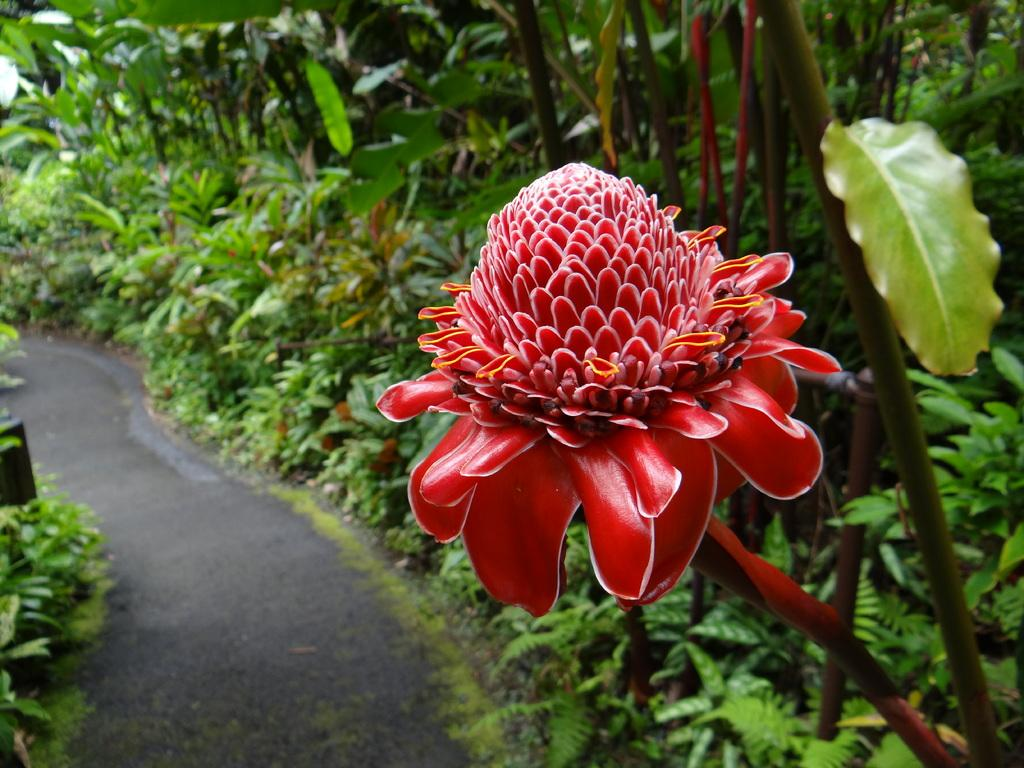What type of vegetation can be seen in the image? There are many trees and plants in the image. What else can be seen in the image besides vegetation? There is a road in the image. Can you describe a specific detail about one of the plants in the image? There is a flower on a plant in the image. What type of punishment is being handed out to the trees in the image? There is no punishment being handed out to the trees in the image; they are simply standing in their natural environment. 